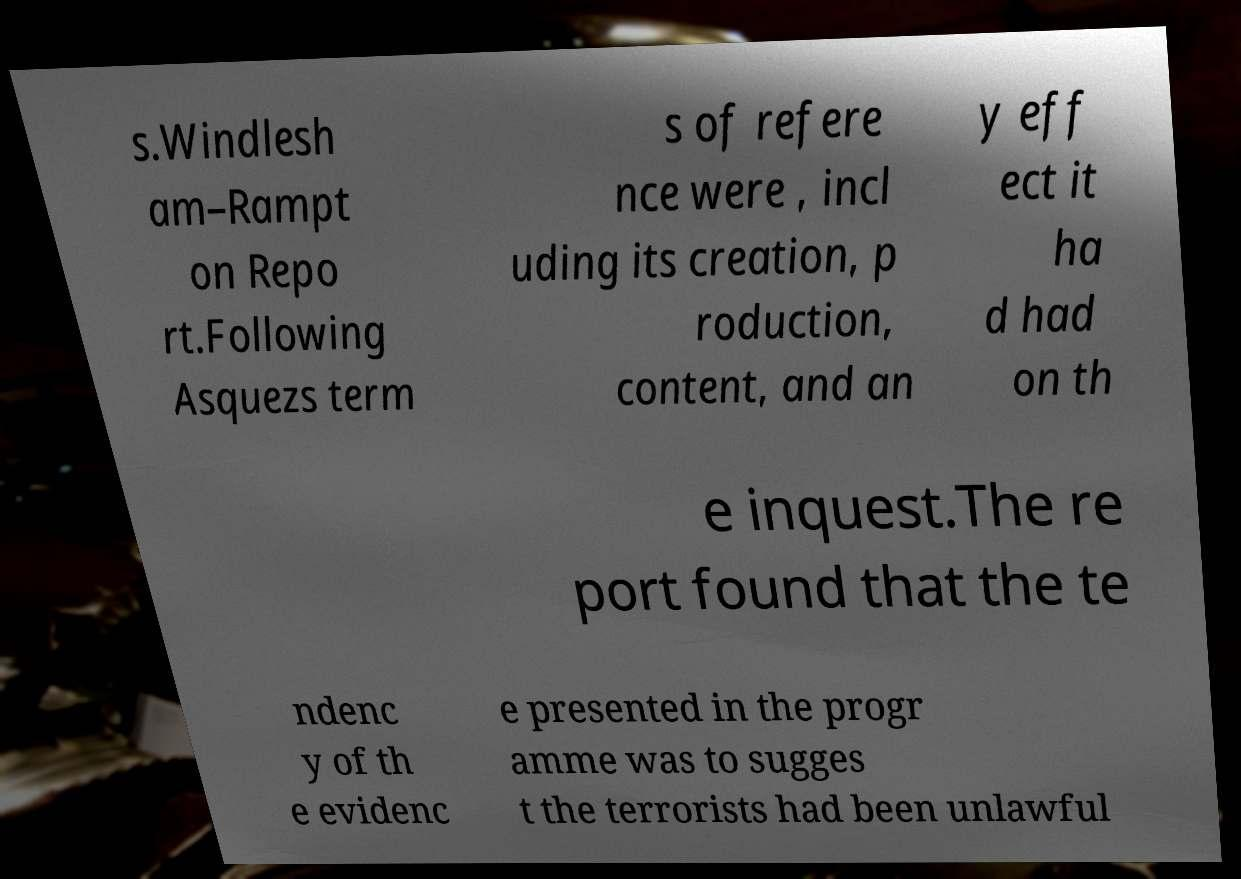Can you read and provide the text displayed in the image?This photo seems to have some interesting text. Can you extract and type it out for me? s.Windlesh am–Rampt on Repo rt.Following Asquezs term s of refere nce were , incl uding its creation, p roduction, content, and an y eff ect it ha d had on th e inquest.The re port found that the te ndenc y of th e evidenc e presented in the progr amme was to sugges t the terrorists had been unlawful 